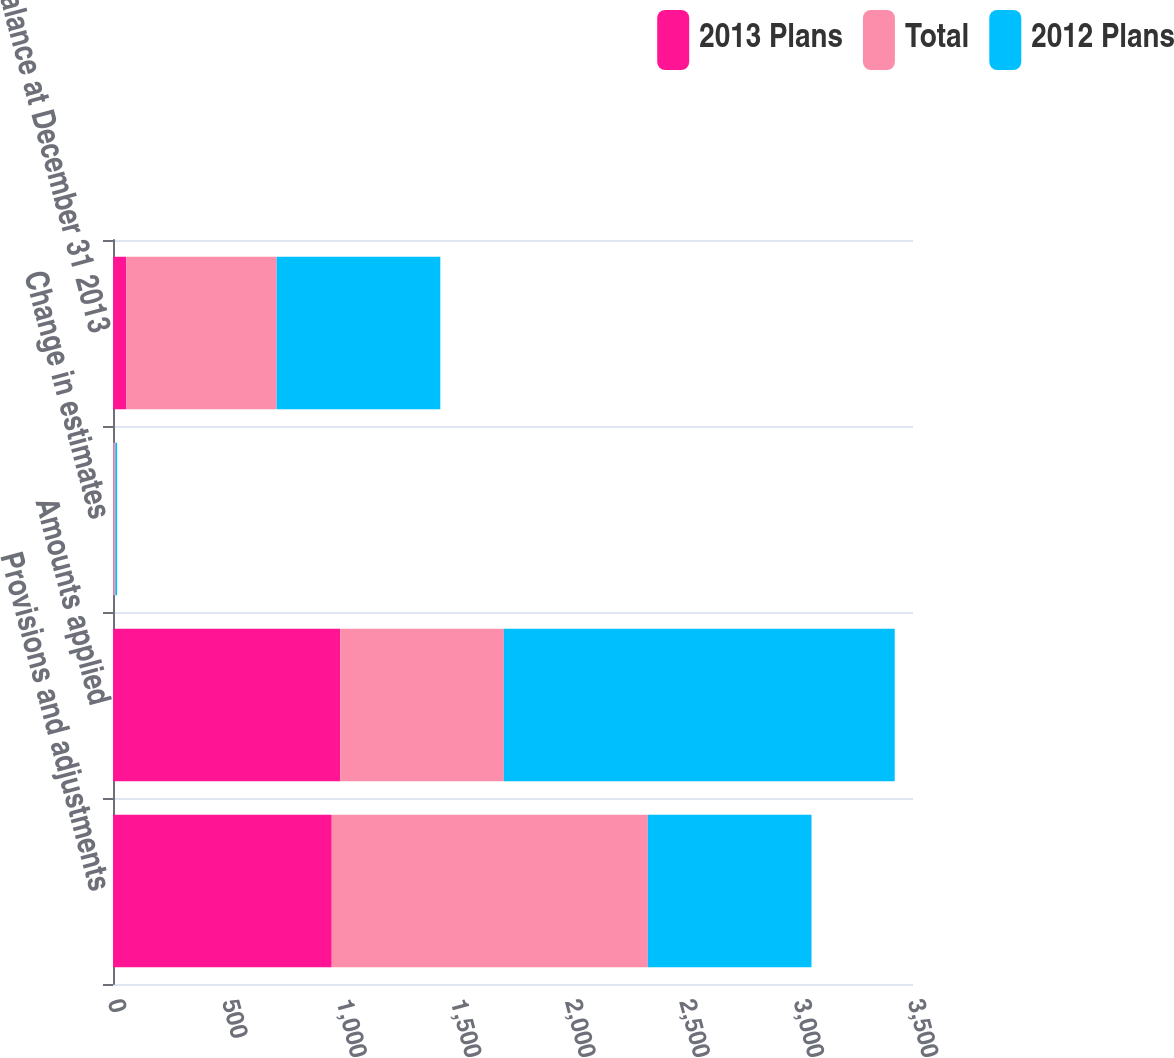<chart> <loc_0><loc_0><loc_500><loc_500><stacked_bar_chart><ecel><fcel>Provisions and adjustments<fcel>Amounts applied<fcel>Change in estimates<fcel>Balance at December 31 2013<nl><fcel>2013 Plans<fcel>957<fcel>994<fcel>1<fcel>58<nl><fcel>Total<fcel>1383<fcel>716<fcel>9<fcel>658<nl><fcel>2012 Plans<fcel>716<fcel>1710<fcel>8<fcel>716<nl></chart> 